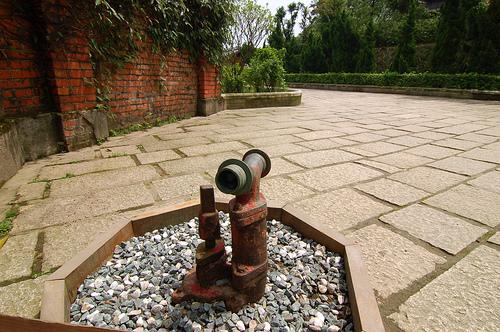Does water come out of the pipes?
Be succinct. Yes. What is growing up through the tiles?
Answer briefly. Moss. What is the purpose of the object in the foreground?
Be succinct. Water. 